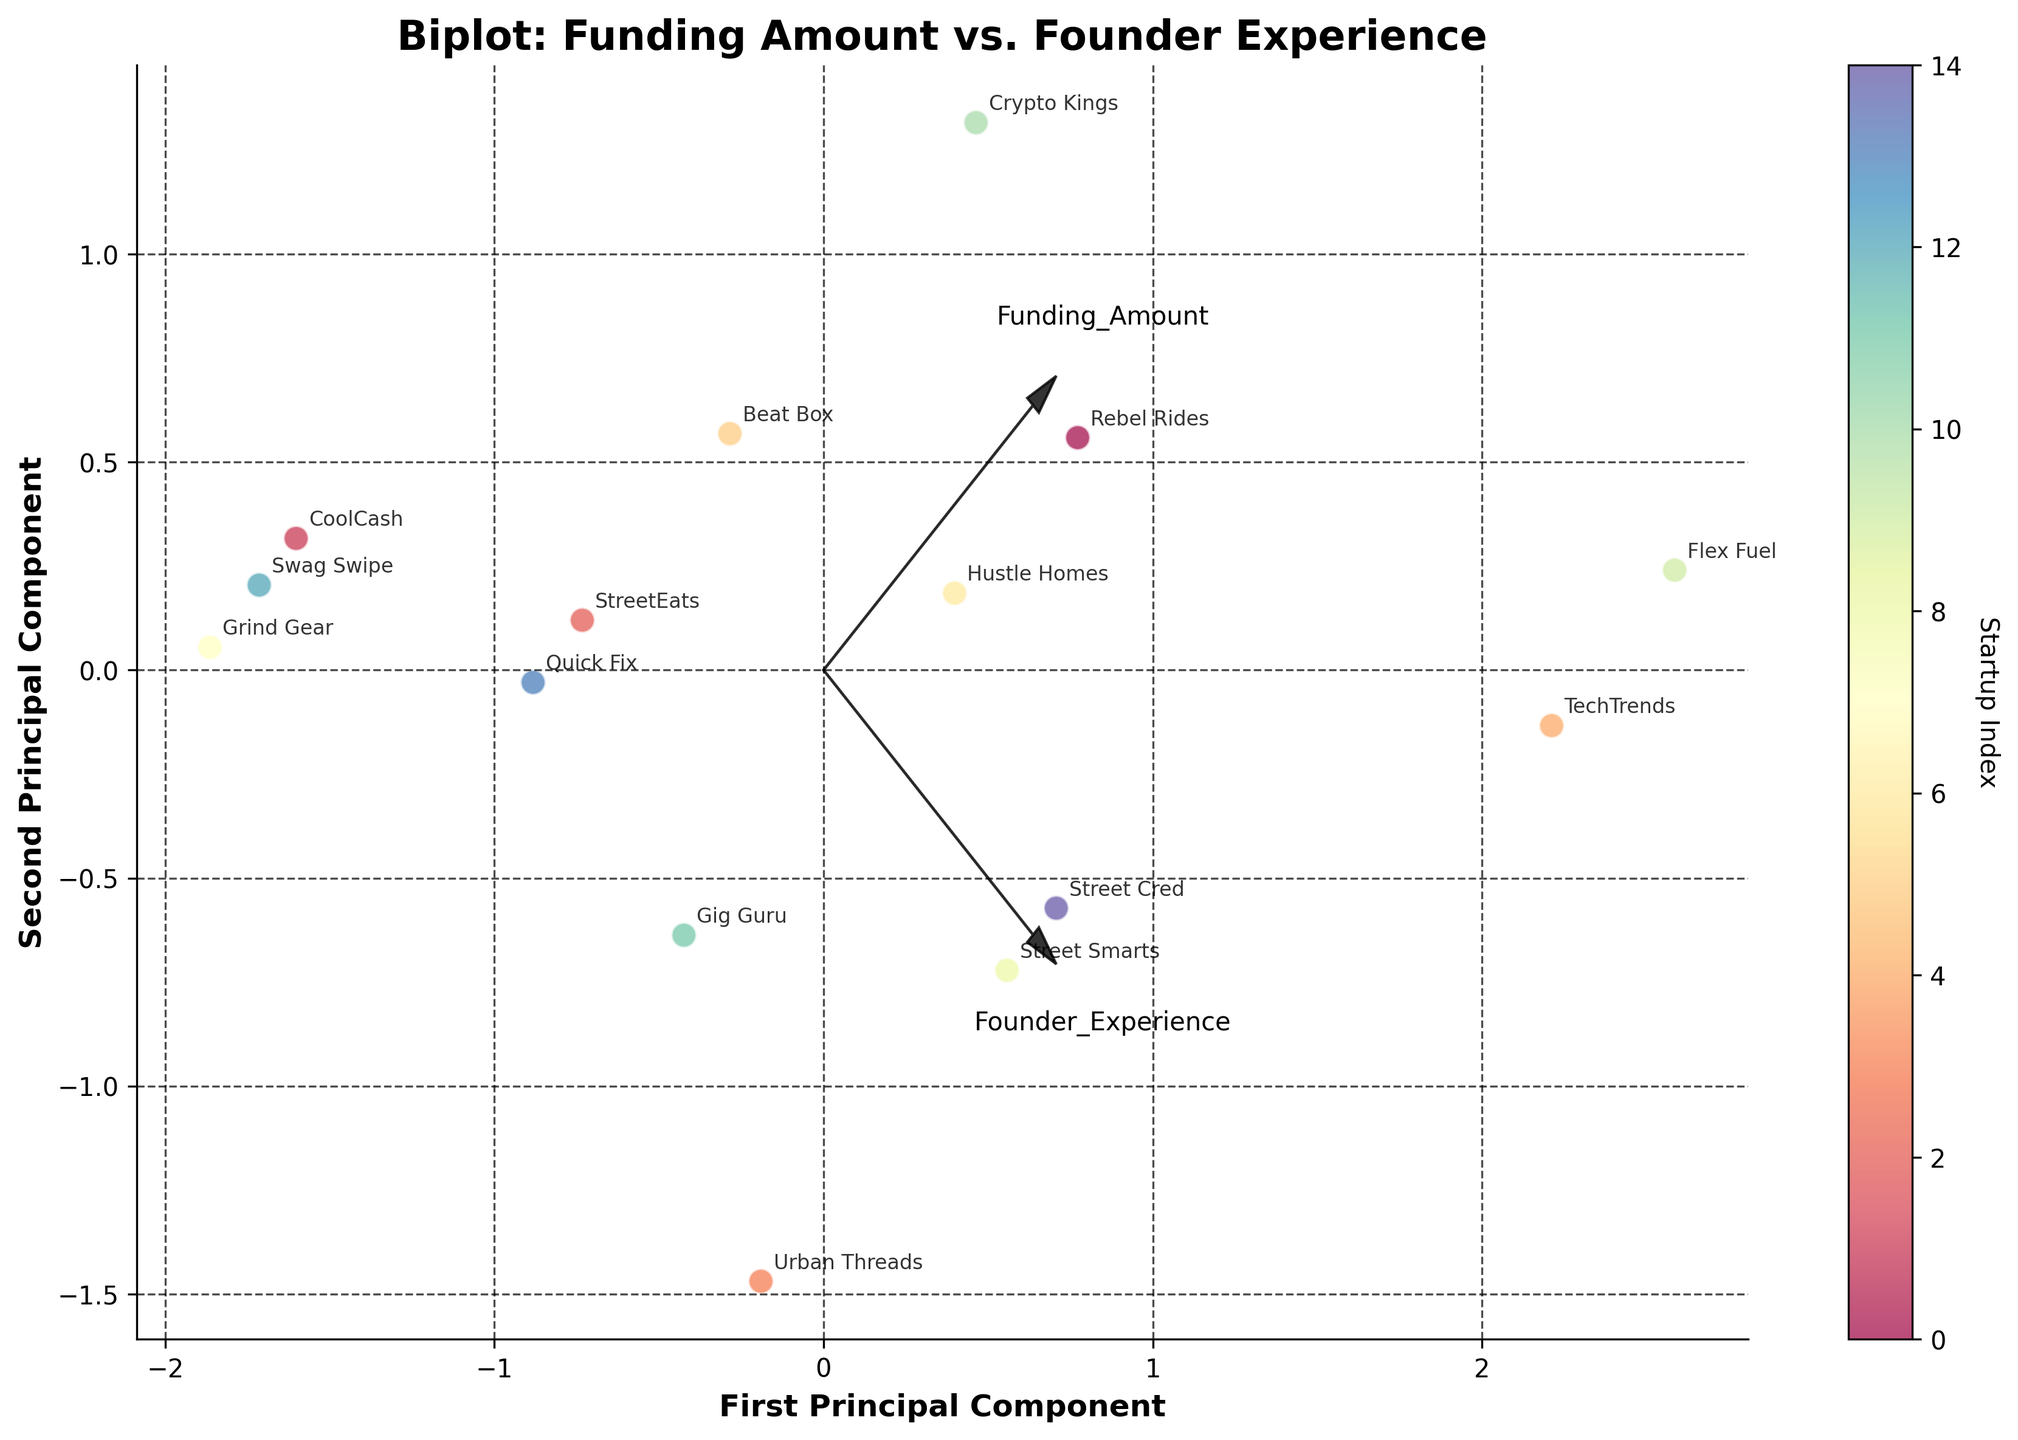Which startup has the highest funding amount? Look for the point that is the farthest along the principal component corresponding to 'Funding Amount' and identify the startup name annotated near that point.
Answer: Flex Fuel Which startup founder has the most experience? Identify the point that is farthest along the principal component corresponding to 'Founder Experience' and find the startup name annotated near that point.
Answer: TechTrends How many startups are in the EdTech industry? Count the number of points and annotations labeled as 'EdTech' and associated with 'Street Smarts'.
Answer: One What's the average experience of founders for startups in the Food Delivery and Music Streaming industries? Identify points for 'StreetEats' and 'Beat Box'. Sum their experience values (2 + 2 = 4) and divide by 2.
Answer: 2 Which startup in the 'Tech News' industry received more funding than $2,000,000? Identify the annotation for 'TechTrends' and check if it is beyond the $2,000,000 mark on the principal component corresponding to 'Funding Amount'.
Answer: TechTrends Compare the funding amounts of 'Crypto Kings' and 'Gig Guru'. Which one received more? Look at the positions of 'Crypto Kings' and 'Gig Guru' relative to the principal component for 'Funding Amount'. 'Crypto Kings' is farther along this component.
Answer: Crypto Kings Which industry has the startup with the highest combination of funding amount and founder experience? Examine points that are farthest along both principal components and identify the associated startup and its industry.
Answer: Clean Energy (Flex Fuel) Is there a positive correlation between funding amount and founder experience based on the biplot? Observe the directions of the principal component vectors for 'Funding Amount' and 'Founder Experience' to see if they point in the same direction.
Answer: Yes 